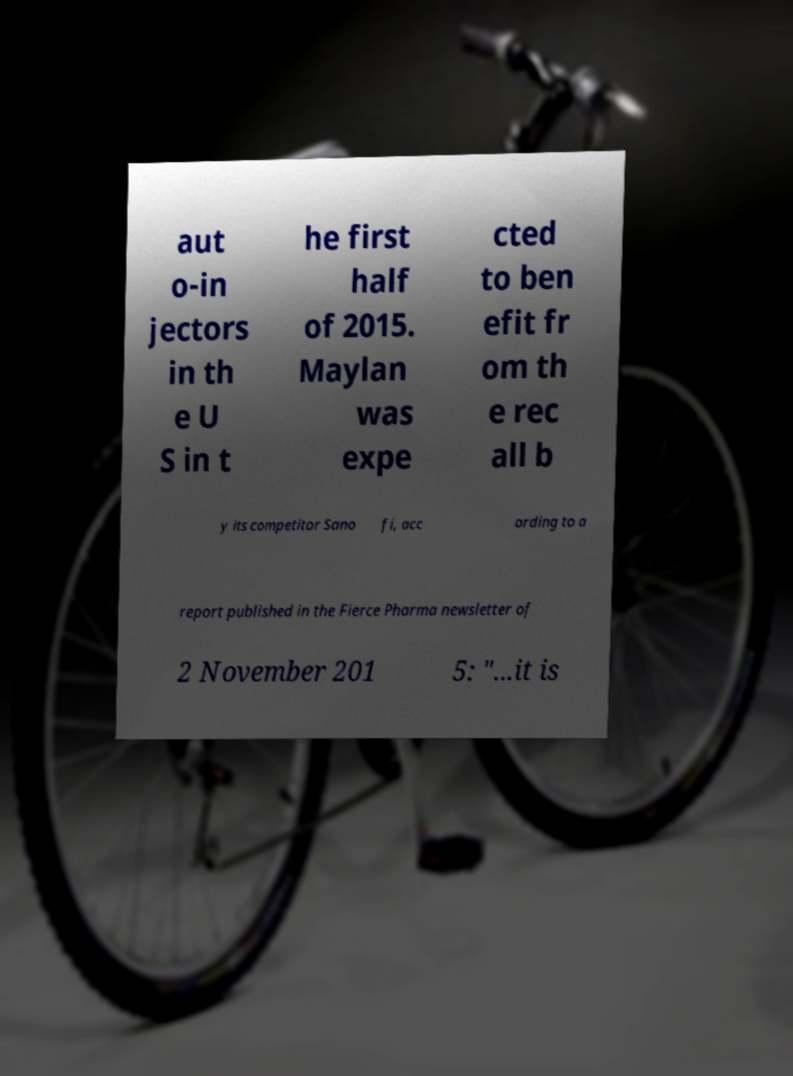Could you extract and type out the text from this image? aut o-in jectors in th e U S in t he first half of 2015. Maylan was expe cted to ben efit fr om th e rec all b y its competitor Sano fi, acc ording to a report published in the Fierce Pharma newsletter of 2 November 201 5: "...it is 